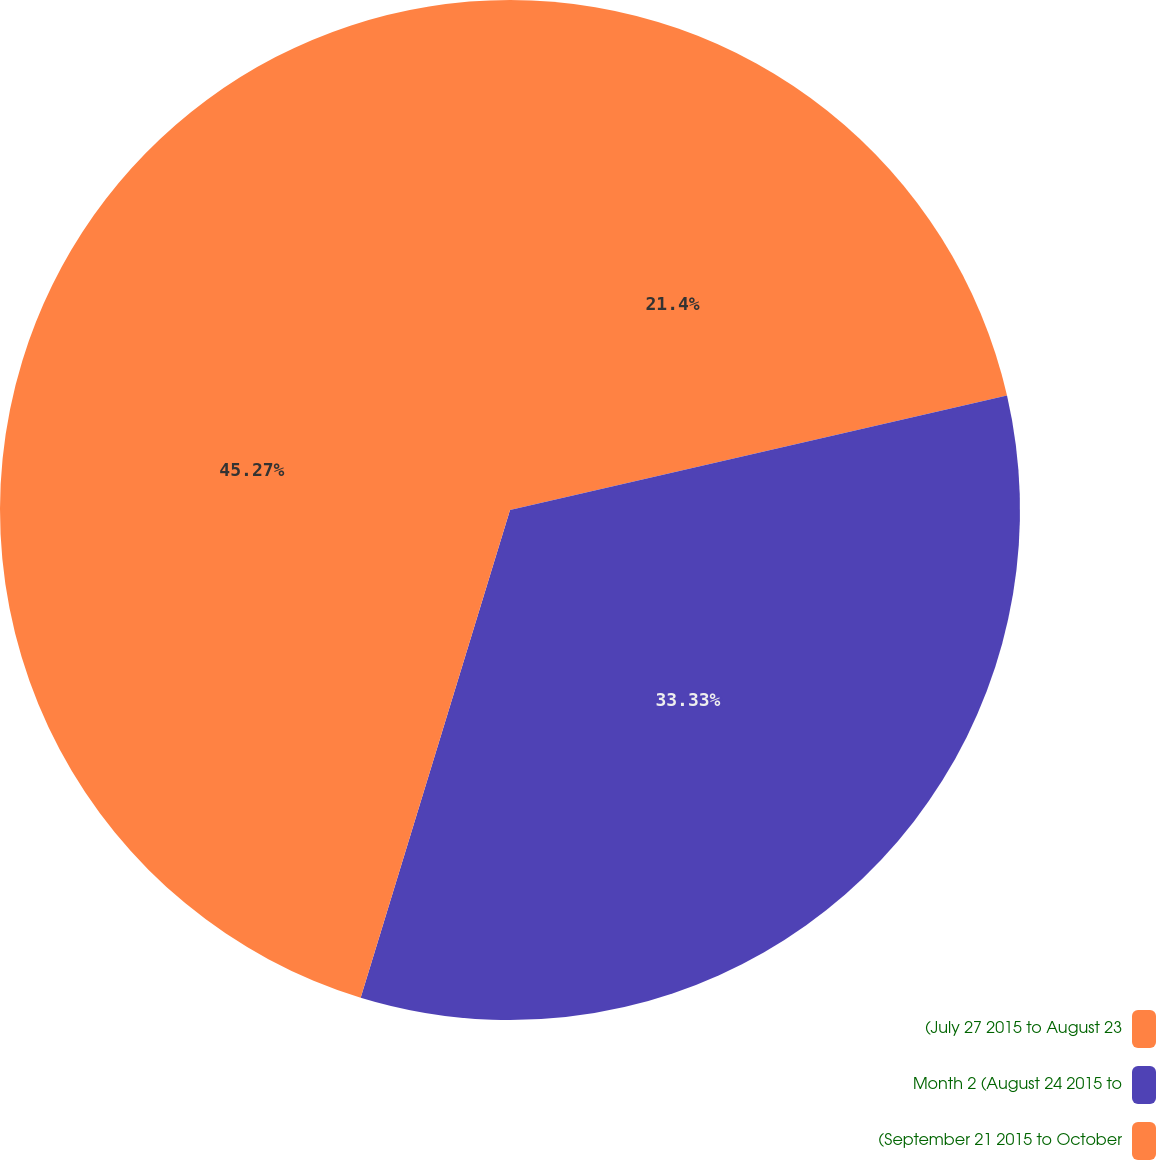Convert chart. <chart><loc_0><loc_0><loc_500><loc_500><pie_chart><fcel>(July 27 2015 to August 23<fcel>Month 2 (August 24 2015 to<fcel>(September 21 2015 to October<nl><fcel>21.4%<fcel>33.33%<fcel>45.27%<nl></chart> 